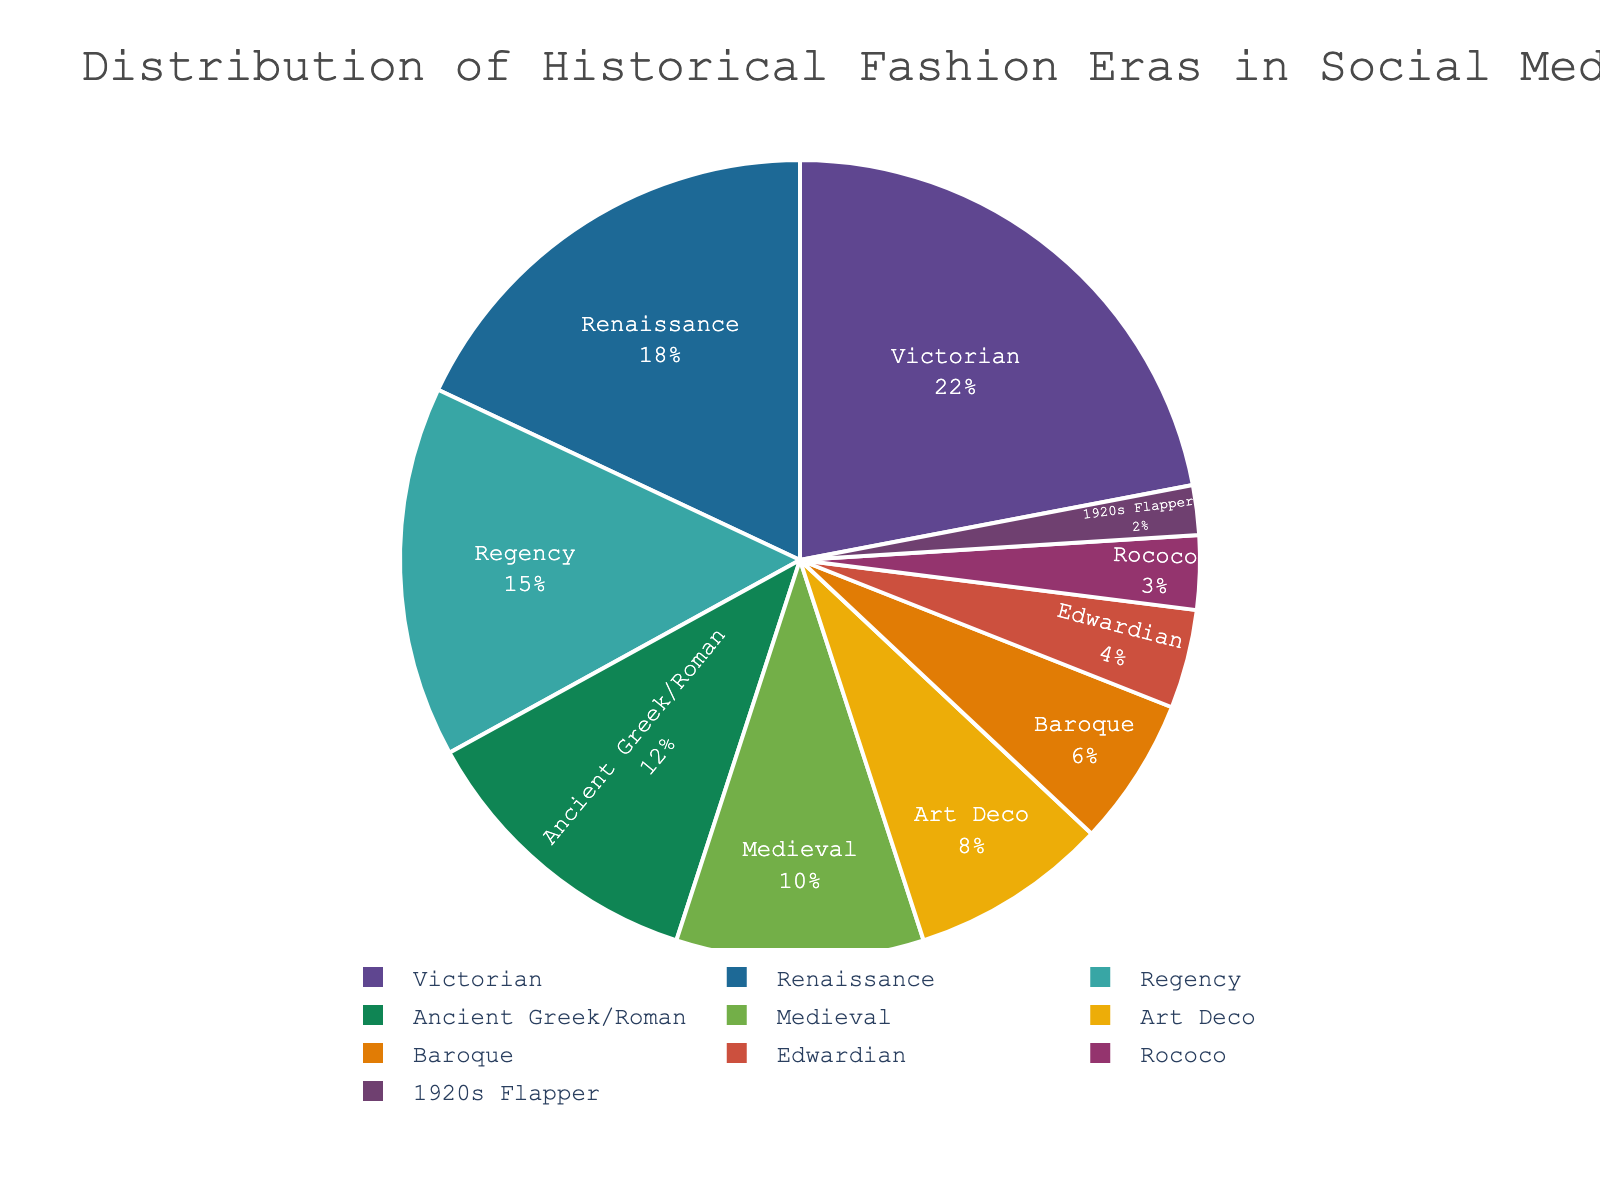What era has the largest representation in the pie chart? To determine the largest representation, look for the segment with the largest percentage. The Victorian era is represented by 22%, which is the highest in the chart.
Answer: Victorian Which era has a higher percentage, Art Deco or Rococo? Compare the values for Art Deco (8%) and Rococo (3%). Art Deco has a higher percentage than Rococo.
Answer: Art Deco What is the combined percentage of Ancient Greek/Roman and Edwardian eras? Add the percentages of Ancient Greek/Roman (12%) and Edwardian (4%). 12% + 4% = 16%.
Answer: 16% How much more popular is the Victorian era compared to the Regency era? Subtract the percentage of the Regency era (15%) from the Victorian era (22%). 22% - 15% = 7%.
Answer: 7% Is the Medieval era more represented than the Baroque era? Compare the percentages of the Medieval (10%) and Baroque (6%) eras. Medieval has a higher percentage than Baroque.
Answer: Yes Which of the eras has the smallest representation in the chart? Look for the segment with the smallest percentage. The 1920s Flapper era has the smallest representation with 2%.
Answer: 1920s Flapper What is the total percentage of fashion eras represented by periods before the 19th century (Ancient Greek/Roman, Medieval, Renaissance, Baroque, and Rococo)? Sum the percentages of Ancient Greek/Roman (12%), Medieval (10%), Renaissance (18%), Baroque (6%), and Rococo (3%). 12% + 10% + 18% + 6% + 3% = 49%.
Answer: 49% Among the Victorian, Regency, and Edwardian eras, which has the median value? Arrange the percentages of these three eras: Victorian (22%), Regency (15%), and Edwardian (4%). The median value is the middle one, which is Regency at 15%.
Answer: Regency Which is more represented, the combination of Renaissance and Edwardian or the combination of Medieval and Art Deco? Sum the percentages of Renaissance (18%) and Edwardian (4%) to get 22%. Sum the percentages of Medieval (10%) and Art Deco (8%) to get 18%. Renaissance and Edwardian combined are more represented.
Answer: Renaissance and Edwardian Is the Art Deco era representation closer to the representation of the Edwardian era or the Medieval era? Calculate the differences: Art Deco (8%) to Edwardian (4%) is 4%, and Art Deco (8%) to Medieval (10%) is 2%. Art Deco is closer to the Medieval era.
Answer: Medieval 